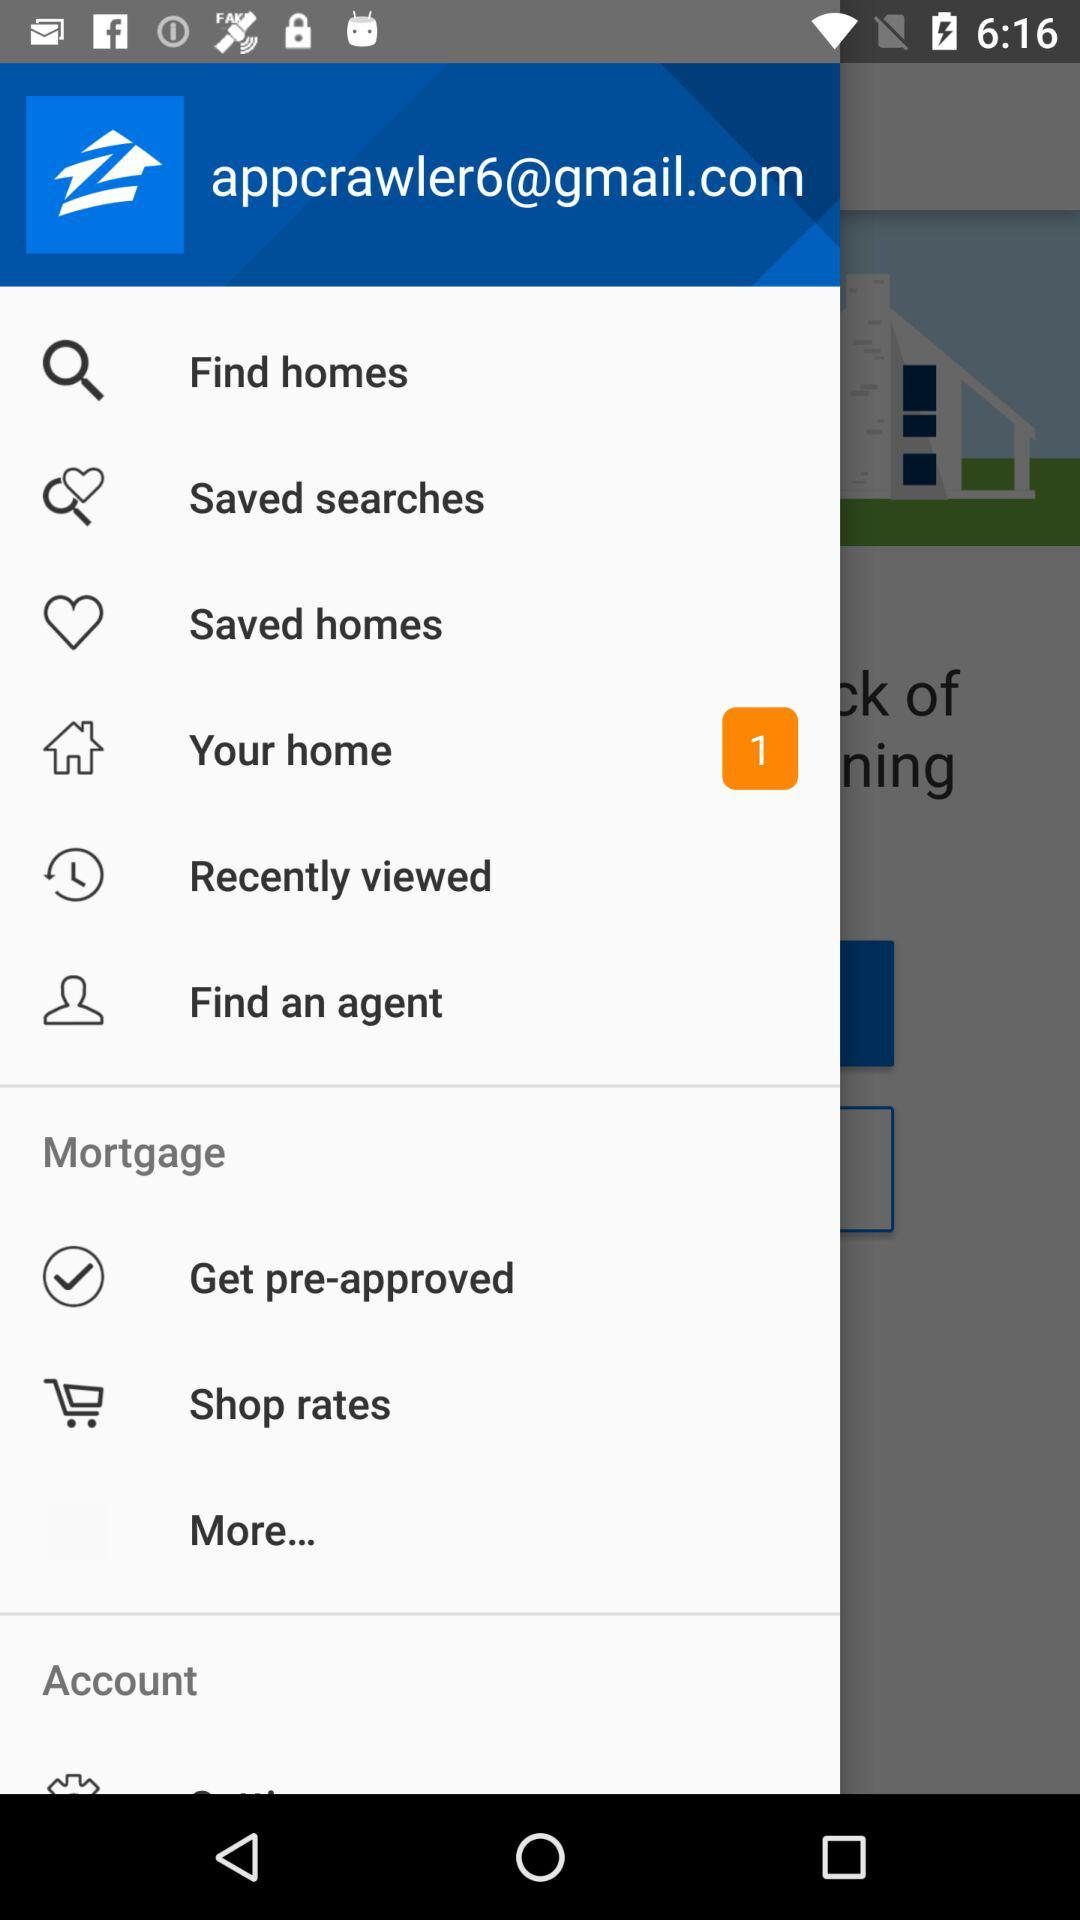How many notifications are there in "Saved searches"?
When the provided information is insufficient, respond with <no answer>. <no answer> 